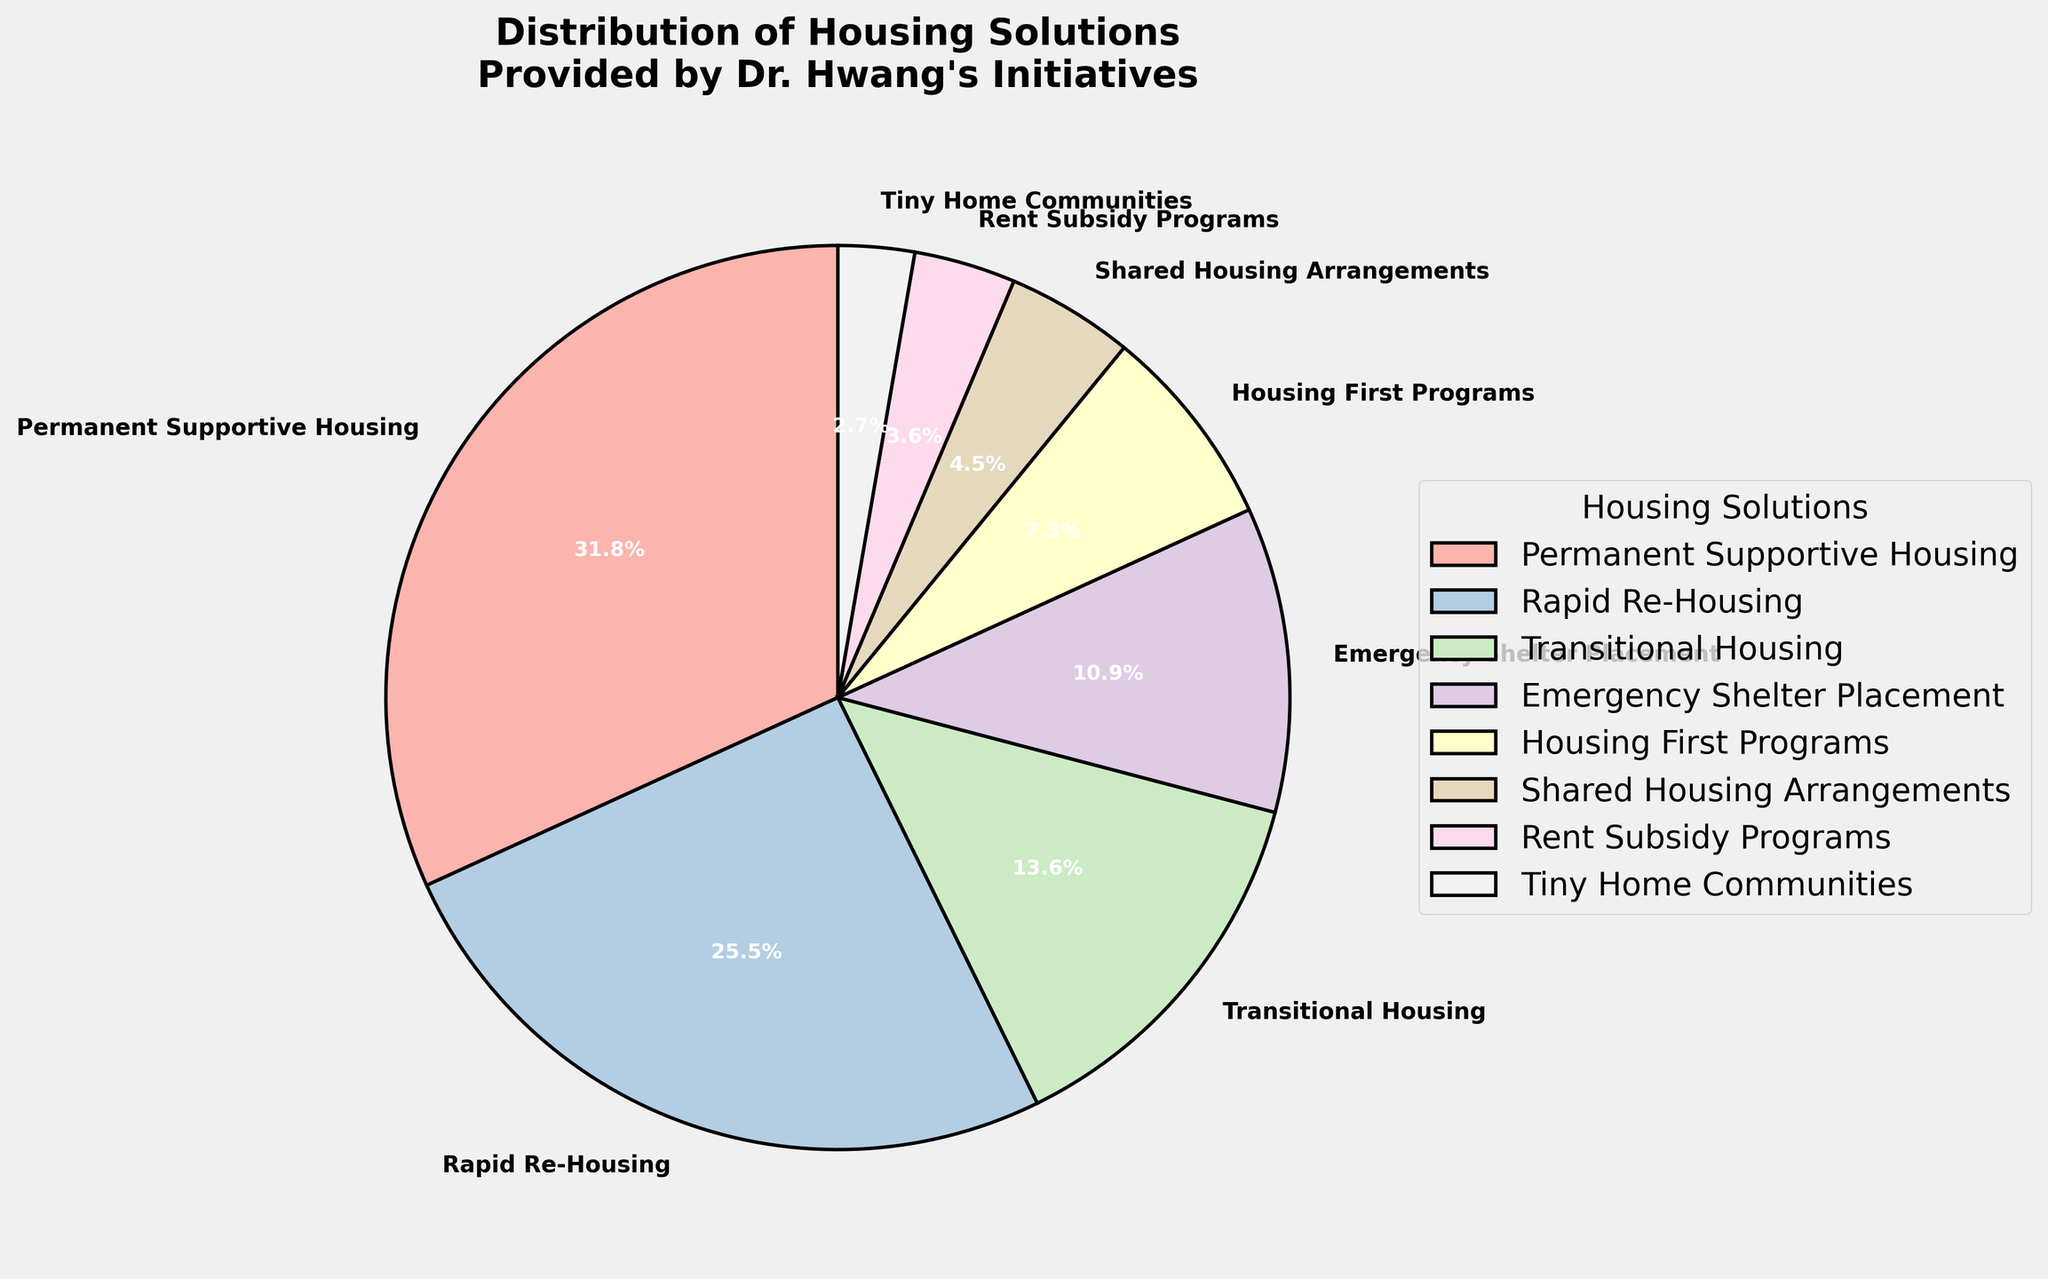Which housing solution has the highest percentage? The pie chart shows that Permanent Supportive Housing has the highest percentage.
Answer: Permanent Supportive Housing Which two housing solutions combined make up over 50% of the total distribution? Adding the percentages of Permanent Supportive Housing (35%) and Rapid Re-Housing (28%), the sum is 35% + 28% = 63%, which is over 50%.
Answer: Permanent Supportive Housing and Rapid Re-Housing Which housing solution has the smallest wedge in the pie chart? From the chart, Tiny Home Communities has the smallest wedge, corresponding to 3%.
Answer: Tiny Home Communities Compare the percentages of Transitional Housing and Emergency Shelter Placement. Which one is greater? Transitional Housing is 15% and Emergency Shelter Placement is 12%. 15% is greater than 12%.
Answer: Transitional Housing How much more is the percentage of Housing First Programs compared to Shared Housing Arrangements? Housing First Programs is at 8% and Shared Housing Arrangements is at 5%. The difference is 8% - 5% = 3%.
Answer: 3% What is the combined percentage of all housing solutions that are under 10% each? Adding up Housing First Programs (8%), Shared Housing Arrangements (5%), Rent Subsidy Programs (4%), and Tiny Home Communities (3%): 8% + 5% + 4% + 3% = 20%.
Answer: 20% Which housing solution is represented with the most visually prominent color (i.e., starting from 12 o'clock position following clockwise)? The wedge starting from the 12 o'clock position clockwise is for Permanent Supportive Housing, indicating it is visually the most prominent one.
Answer: Permanent Supportive Housing What is the largest difference in percentage between any two adjacent categories on the pie chart? The largest difference between any two adjacent categories is between Permanent Supportive Housing (35%) and Rapid Re-Housing (28%), which is 35% - 28% = 7%.
Answer: 7% 